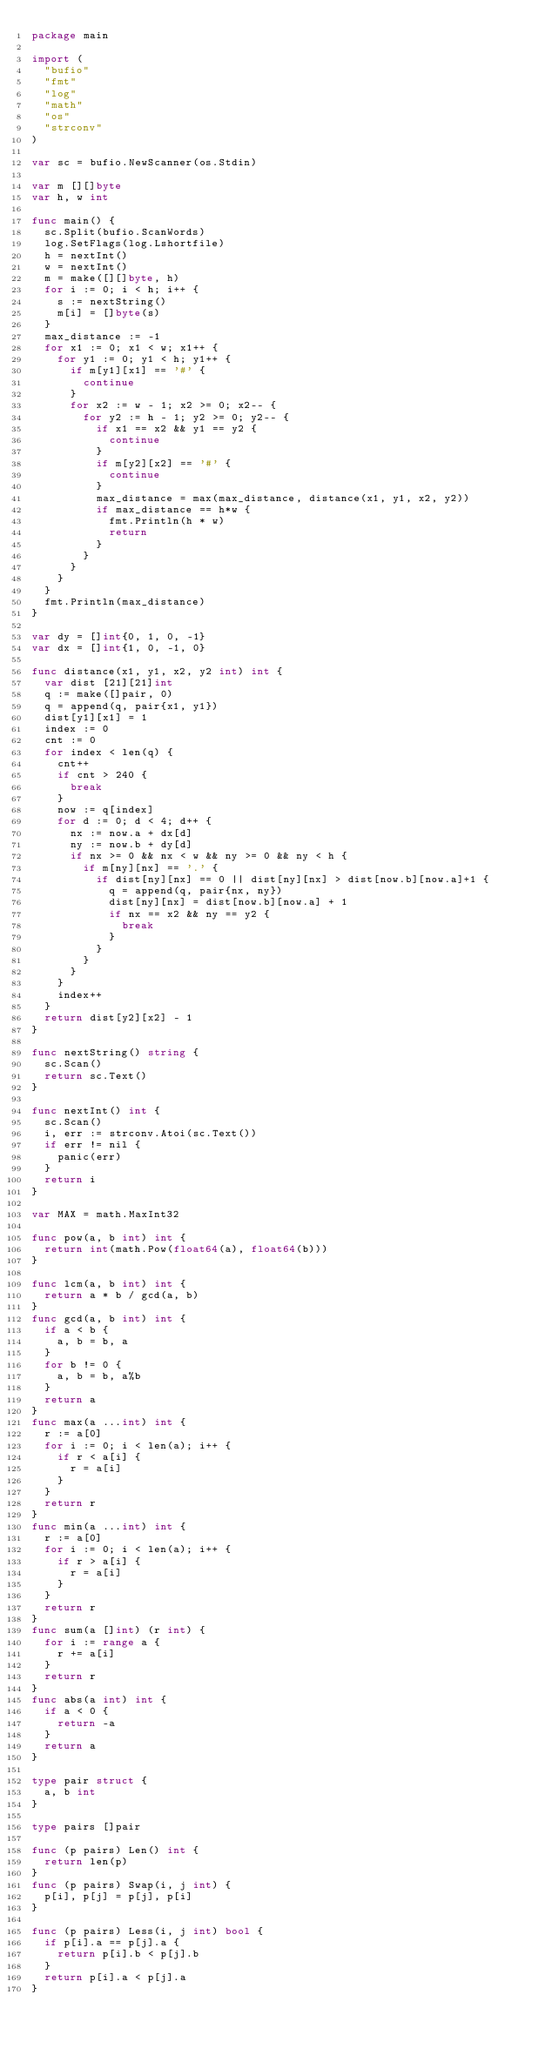<code> <loc_0><loc_0><loc_500><loc_500><_Go_>package main

import (
	"bufio"
	"fmt"
	"log"
	"math"
	"os"
	"strconv"
)

var sc = bufio.NewScanner(os.Stdin)

var m [][]byte
var h, w int

func main() {
	sc.Split(bufio.ScanWords)
	log.SetFlags(log.Lshortfile)
	h = nextInt()
	w = nextInt()
	m = make([][]byte, h)
	for i := 0; i < h; i++ {
		s := nextString()
		m[i] = []byte(s)
	}
	max_distance := -1
	for x1 := 0; x1 < w; x1++ {
		for y1 := 0; y1 < h; y1++ {
			if m[y1][x1] == '#' {
				continue
			}
			for x2 := w - 1; x2 >= 0; x2-- {
				for y2 := h - 1; y2 >= 0; y2-- {
					if x1 == x2 && y1 == y2 {
						continue
					}
					if m[y2][x2] == '#' {
						continue
					}
					max_distance = max(max_distance, distance(x1, y1, x2, y2))
					if max_distance == h*w {
						fmt.Println(h * w)
						return
					}
				}
			}
		}
	}
	fmt.Println(max_distance)
}

var dy = []int{0, 1, 0, -1}
var dx = []int{1, 0, -1, 0}

func distance(x1, y1, x2, y2 int) int {
	var dist [21][21]int
	q := make([]pair, 0)
	q = append(q, pair{x1, y1})
	dist[y1][x1] = 1
	index := 0
	cnt := 0
	for index < len(q) {
		cnt++
		if cnt > 240 {
			break
		}
		now := q[index]
		for d := 0; d < 4; d++ {
			nx := now.a + dx[d]
			ny := now.b + dy[d]
			if nx >= 0 && nx < w && ny >= 0 && ny < h {
				if m[ny][nx] == '.' {
					if dist[ny][nx] == 0 || dist[ny][nx] > dist[now.b][now.a]+1 {
						q = append(q, pair{nx, ny})
						dist[ny][nx] = dist[now.b][now.a] + 1
						if nx == x2 && ny == y2 {
							break
						}
					}
				}
			}
		}
		index++
	}
	return dist[y2][x2] - 1
}

func nextString() string {
	sc.Scan()
	return sc.Text()
}

func nextInt() int {
	sc.Scan()
	i, err := strconv.Atoi(sc.Text())
	if err != nil {
		panic(err)
	}
	return i
}

var MAX = math.MaxInt32

func pow(a, b int) int {
	return int(math.Pow(float64(a), float64(b)))
}

func lcm(a, b int) int {
	return a * b / gcd(a, b)
}
func gcd(a, b int) int {
	if a < b {
		a, b = b, a
	}
	for b != 0 {
		a, b = b, a%b
	}
	return a
}
func max(a ...int) int {
	r := a[0]
	for i := 0; i < len(a); i++ {
		if r < a[i] {
			r = a[i]
		}
	}
	return r
}
func min(a ...int) int {
	r := a[0]
	for i := 0; i < len(a); i++ {
		if r > a[i] {
			r = a[i]
		}
	}
	return r
}
func sum(a []int) (r int) {
	for i := range a {
		r += a[i]
	}
	return r
}
func abs(a int) int {
	if a < 0 {
		return -a
	}
	return a
}

type pair struct {
	a, b int
}

type pairs []pair

func (p pairs) Len() int {
	return len(p)
}
func (p pairs) Swap(i, j int) {
	p[i], p[j] = p[j], p[i]
}

func (p pairs) Less(i, j int) bool {
	if p[i].a == p[j].a {
		return p[i].b < p[j].b
	}
	return p[i].a < p[j].a
}
</code> 